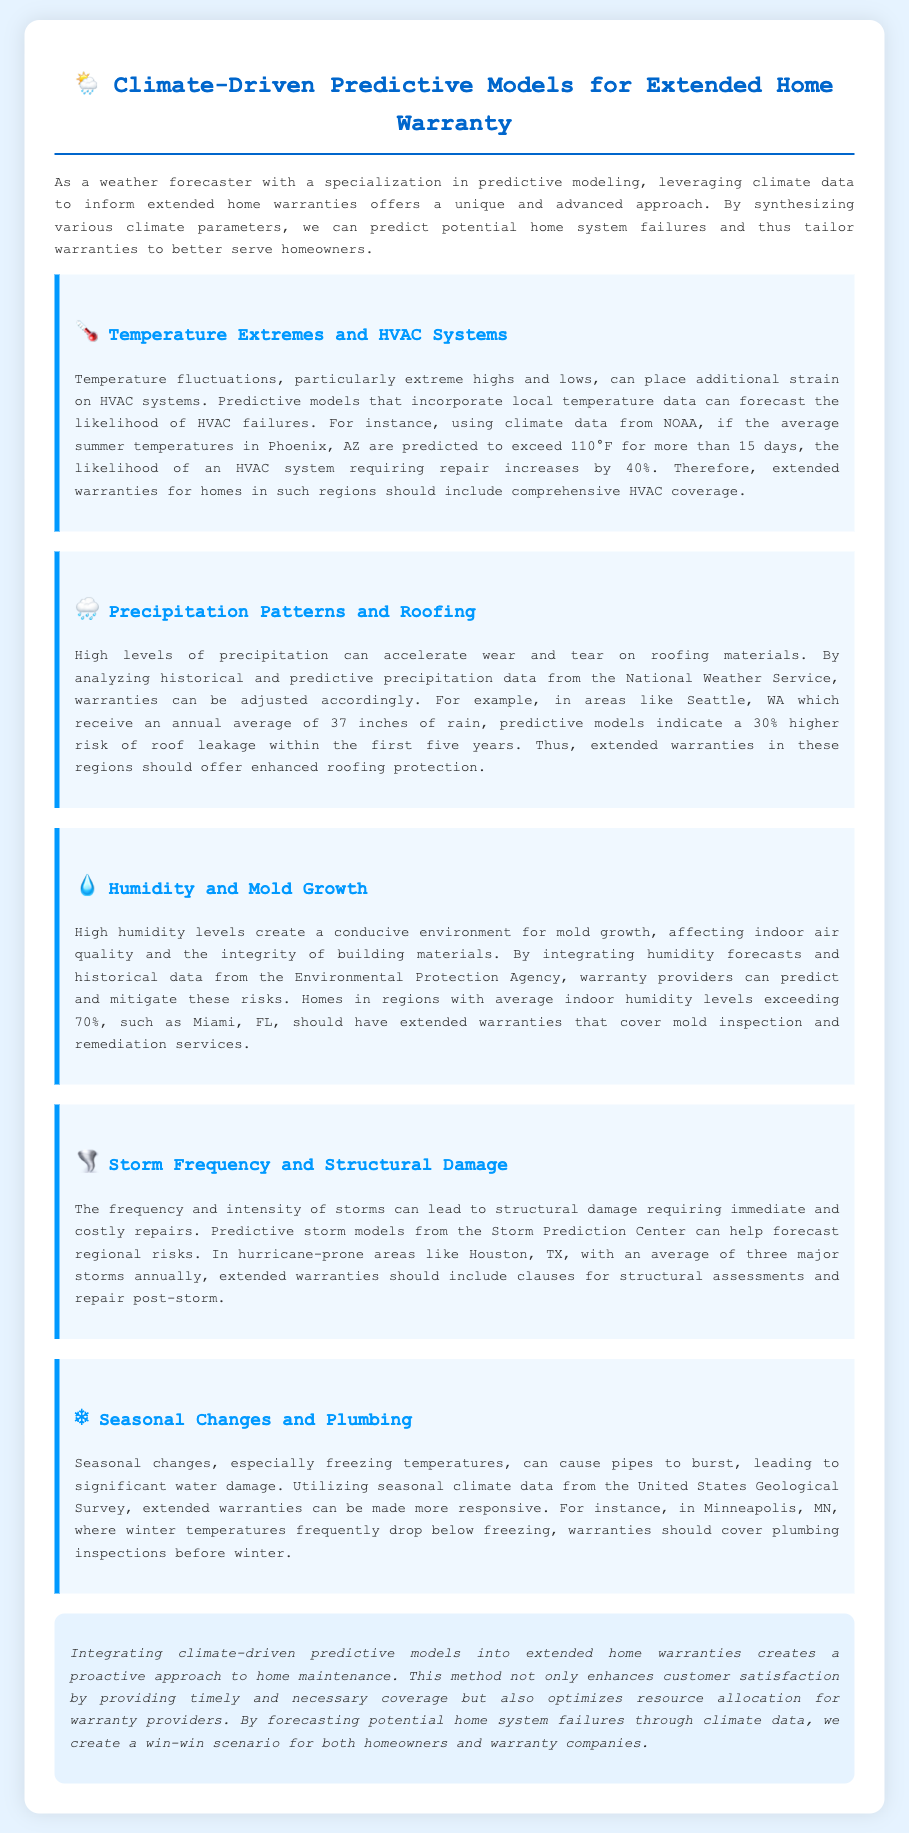What is the predicted increase in HVAC failure likelihood in Phoenix? The document states that the likelihood of an HVAC system requiring repair increases by 40% if the average summer temperatures exceed 110°F for more than 15 days.
Answer: 40% What is the average annual precipitation in Seattle? The document mentions that Seattle receives an annual average of 37 inches of rain.
Answer: 37 inches What humidity level indicates a higher risk for mold in Miami? The document specifies that average indoor humidity levels exceeding 70% pose a risk for mold growth.
Answer: 70% How many major storms does Houston experience annually? According to the document, Houston has an average of three major storms annually.
Answer: three What coverage should warranties include in storm-prone areas? The document suggests that extended warranties should include clauses for structural assessments and repair post-storm.
Answer: structural assessments and repair post-storm What statistical data is used for humidity forecasts? The document states that humidity forecasts and historical data are integrated from the Environmental Protection Agency.
Answer: Environmental Protection Agency What is the impact of temperature extremes on HVAC systems? The document explains that extreme temperatures place additional strain on HVAC systems, leading to potential failures.
Answer: additional strain on HVAC systems What maintenance is advised for homes in Minneapolis before winter? The document recommends covering plumbing inspections before winter in areas like Minneapolis where temperatures drop below freezing.
Answer: plumbing inspections before winter 